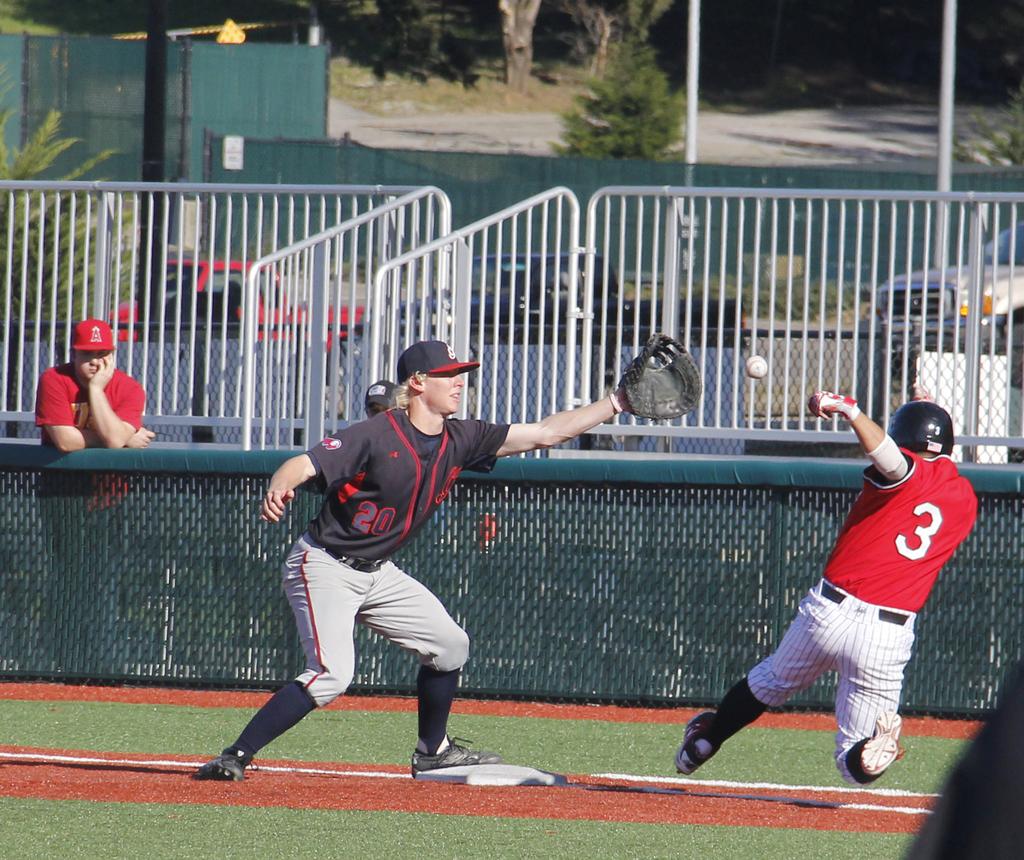What is the jersey number of the player trying to slide to the base?
Offer a very short reply. 3. What number is on the black jersey?
Provide a short and direct response. 20. 